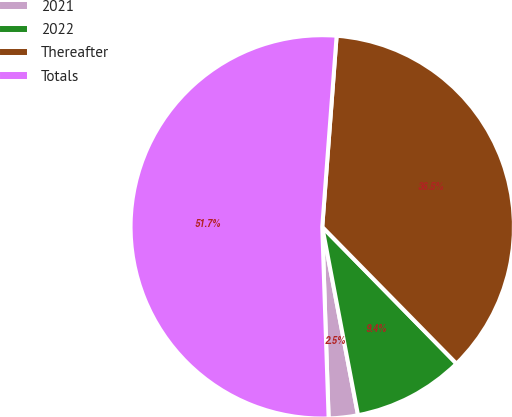Convert chart to OTSL. <chart><loc_0><loc_0><loc_500><loc_500><pie_chart><fcel>2021<fcel>2022<fcel>Thereafter<fcel>Totals<nl><fcel>2.46%<fcel>9.36%<fcel>36.45%<fcel>51.72%<nl></chart> 